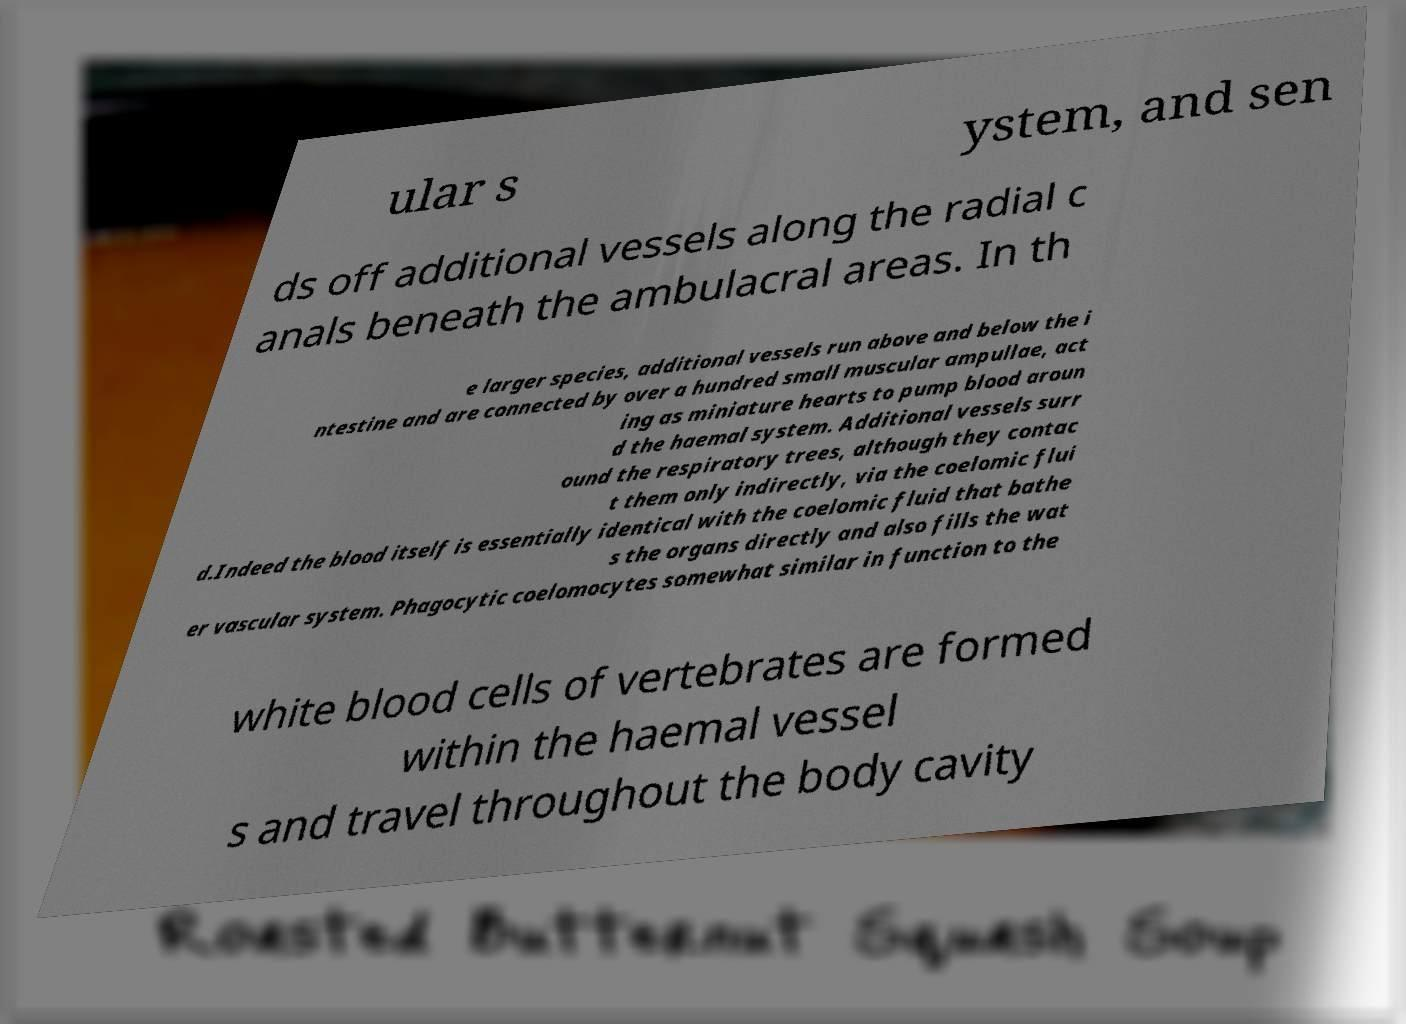What messages or text are displayed in this image? I need them in a readable, typed format. ular s ystem, and sen ds off additional vessels along the radial c anals beneath the ambulacral areas. In th e larger species, additional vessels run above and below the i ntestine and are connected by over a hundred small muscular ampullae, act ing as miniature hearts to pump blood aroun d the haemal system. Additional vessels surr ound the respiratory trees, although they contac t them only indirectly, via the coelomic flui d.Indeed the blood itself is essentially identical with the coelomic fluid that bathe s the organs directly and also fills the wat er vascular system. Phagocytic coelomocytes somewhat similar in function to the white blood cells of vertebrates are formed within the haemal vessel s and travel throughout the body cavity 